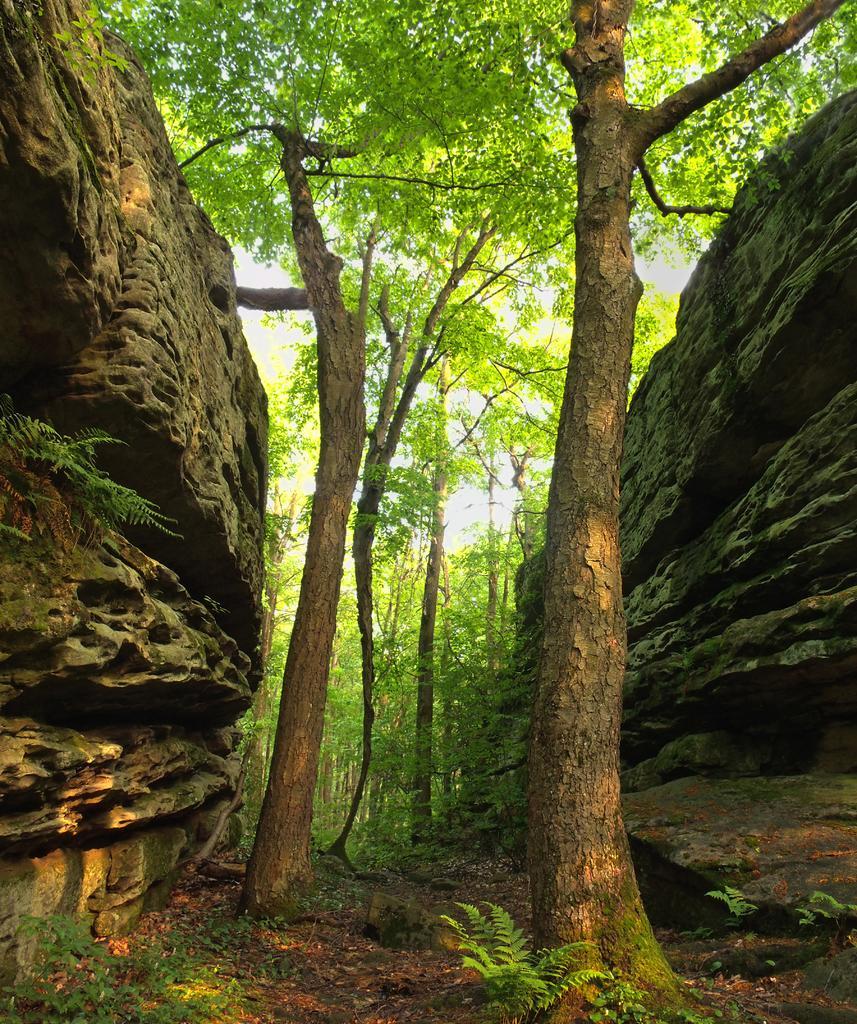How would you summarize this image in a sentence or two? In this image there are trees and there's grass on the ground, On the left side there is a rock. 